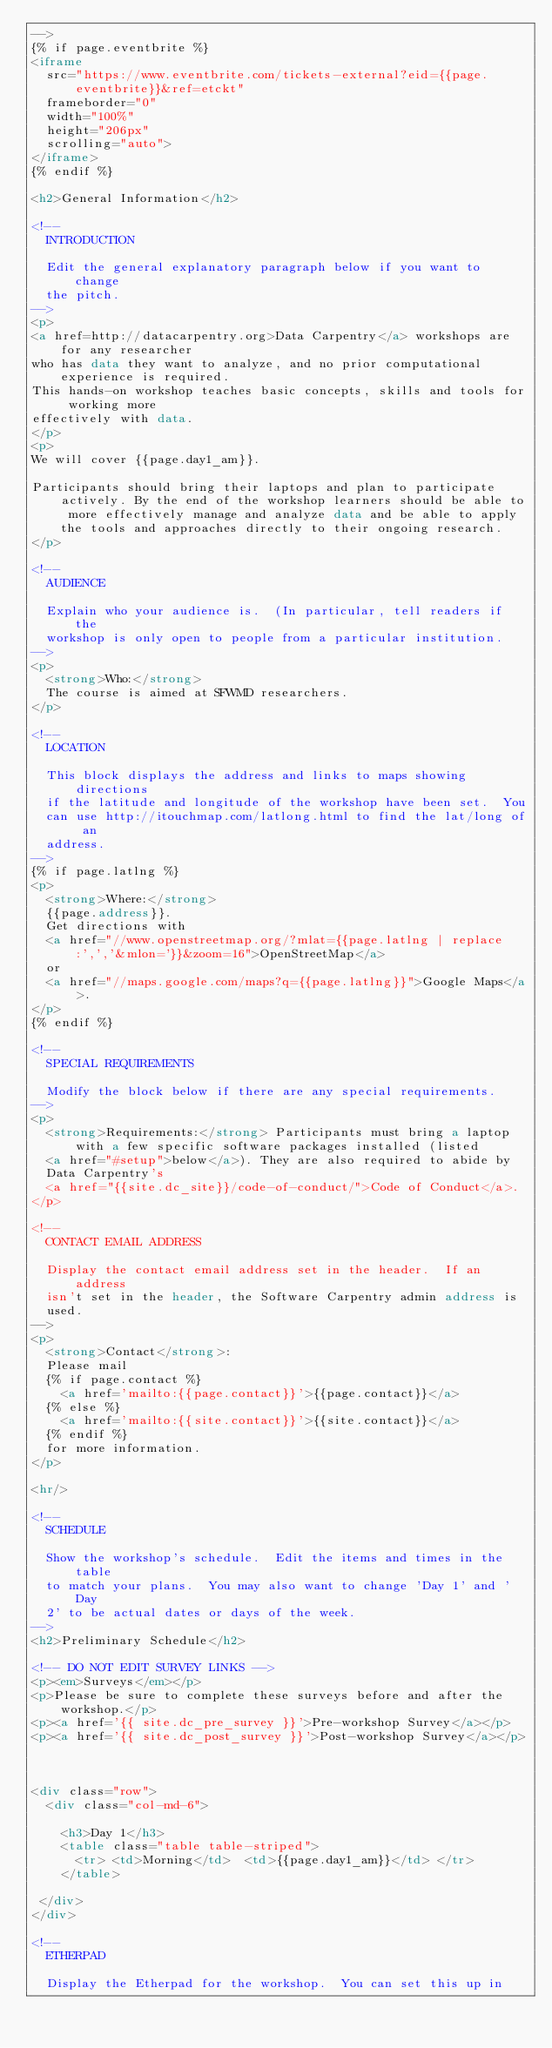<code> <loc_0><loc_0><loc_500><loc_500><_HTML_>-->
{% if page.eventbrite %}
<iframe
  src="https://www.eventbrite.com/tickets-external?eid={{page.eventbrite}}&ref=etckt"
  frameborder="0"
  width="100%"
  height="206px"
  scrolling="auto">
</iframe>
{% endif %}

<h2>General Information</h2>

<!--
  INTRODUCTION

  Edit the general explanatory paragraph below if you want to change
  the pitch.
-->
<p>
<a href=http://datacarpentry.org>Data Carpentry</a> workshops are for any researcher 
who has data they want to analyze, and no prior computational experience is required. 
This hands-on workshop teaches basic concepts, skills and tools for working more 
effectively with data. 
</p>
<p>
We will cover {{page.day1_am}}.

Participants should bring their laptops and plan to participate actively. By the end of the workshop learners should be able to more effectively manage and analyze data and be able to apply the tools and approaches directly to their ongoing research.
</p>

<!--
  AUDIENCE

  Explain who your audience is.  (In particular, tell readers if the
  workshop is only open to people from a particular institution.
-->
<p>
  <strong>Who:</strong>
  The course is aimed at SFWMD researchers.
</p>

<!--
  LOCATION

  This block displays the address and links to maps showing directions
  if the latitude and longitude of the workshop have been set.  You
  can use http://itouchmap.com/latlong.html to find the lat/long of an
  address.
-->
{% if page.latlng %}
<p>
  <strong>Where:</strong>
  {{page.address}}.
  Get directions with
  <a href="//www.openstreetmap.org/?mlat={{page.latlng | replace:',','&mlon='}}&zoom=16">OpenStreetMap</a>
  or
  <a href="//maps.google.com/maps?q={{page.latlng}}">Google Maps</a>.
</p>
{% endif %}

<!--
  SPECIAL REQUIREMENTS

  Modify the block below if there are any special requirements.
-->
<p>
  <strong>Requirements:</strong> Participants must bring a laptop with a few specific software packages installed (listed
  <a href="#setup">below</a>). They are also required to abide by
  Data Carpentry's
  <a href="{{site.dc_site}}/code-of-conduct/">Code of Conduct</a>.
</p>

<!--
  CONTACT EMAIL ADDRESS

  Display the contact email address set in the header.  If an address
  isn't set in the header, the Software Carpentry admin address is
  used.
-->
<p>
  <strong>Contact</strong>:
  Please mail
  {% if page.contact %}
    <a href='mailto:{{page.contact}}'>{{page.contact}}</a>
  {% else %}
    <a href='mailto:{{site.contact}}'>{{site.contact}}</a>
  {% endif %}
  for more information.
</p>

<hr/>

<!--
  SCHEDULE

  Show the workshop's schedule.  Edit the items and times in the table
  to match your plans.  You may also want to change 'Day 1' and 'Day
  2' to be actual dates or days of the week.
-->
<h2>Preliminary Schedule</h2>

<!-- DO NOT EDIT SURVEY LINKS -->
<p><em>Surveys</em></p>
<p>Please be sure to complete these surveys before and after the workshop.</p>
<p><a href='{{ site.dc_pre_survey }}'>Pre-workshop Survey</a></p>
<p><a href='{{ site.dc_post_survey }}'>Post-workshop Survey</a></p>



<div class="row">
  <div class="col-md-6">

    <h3>Day 1</h3>
    <table class="table table-striped">
      <tr> <td>Morning</td>  <td>{{page.day1_am}}</td> </tr>
    </table>
    
 </div>
</div>

<!--
  ETHERPAD

  Display the Etherpad for the workshop.  You can set this up in</code> 